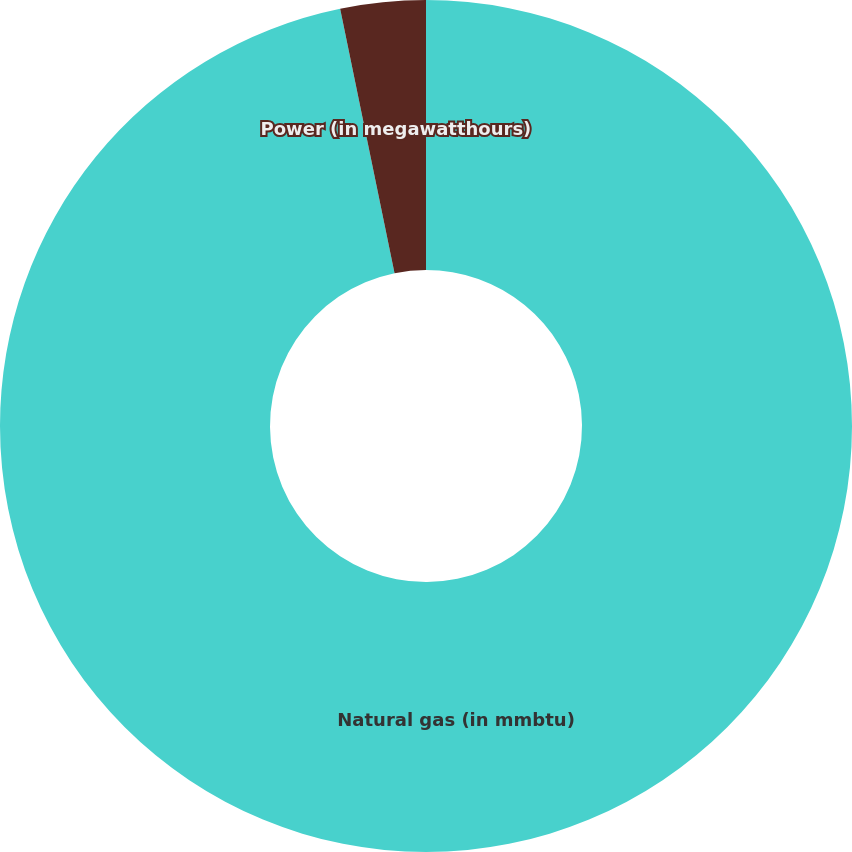<chart> <loc_0><loc_0><loc_500><loc_500><pie_chart><fcel>Natural gas (in mmbtu)<fcel>Power (in megawatthours)<nl><fcel>96.77%<fcel>3.23%<nl></chart> 